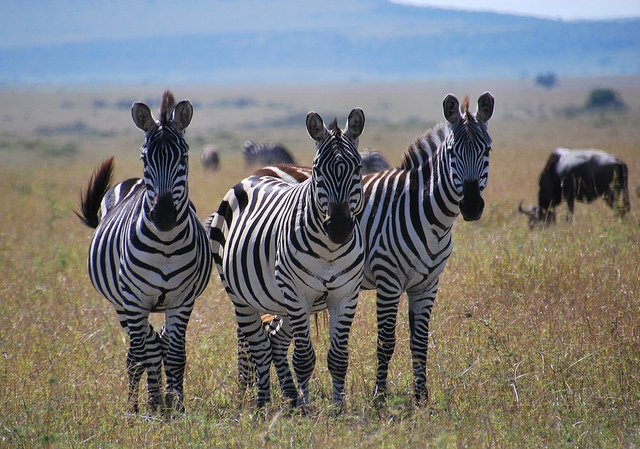Describe the objects in this image and their specific colors. I can see zebra in darkgray, black, gray, and lightgray tones, zebra in darkgray, black, gray, and navy tones, zebra in darkgray, black, and gray tones, cow in darkgray, black, and gray tones, and zebra in darkgray, gray, and black tones in this image. 